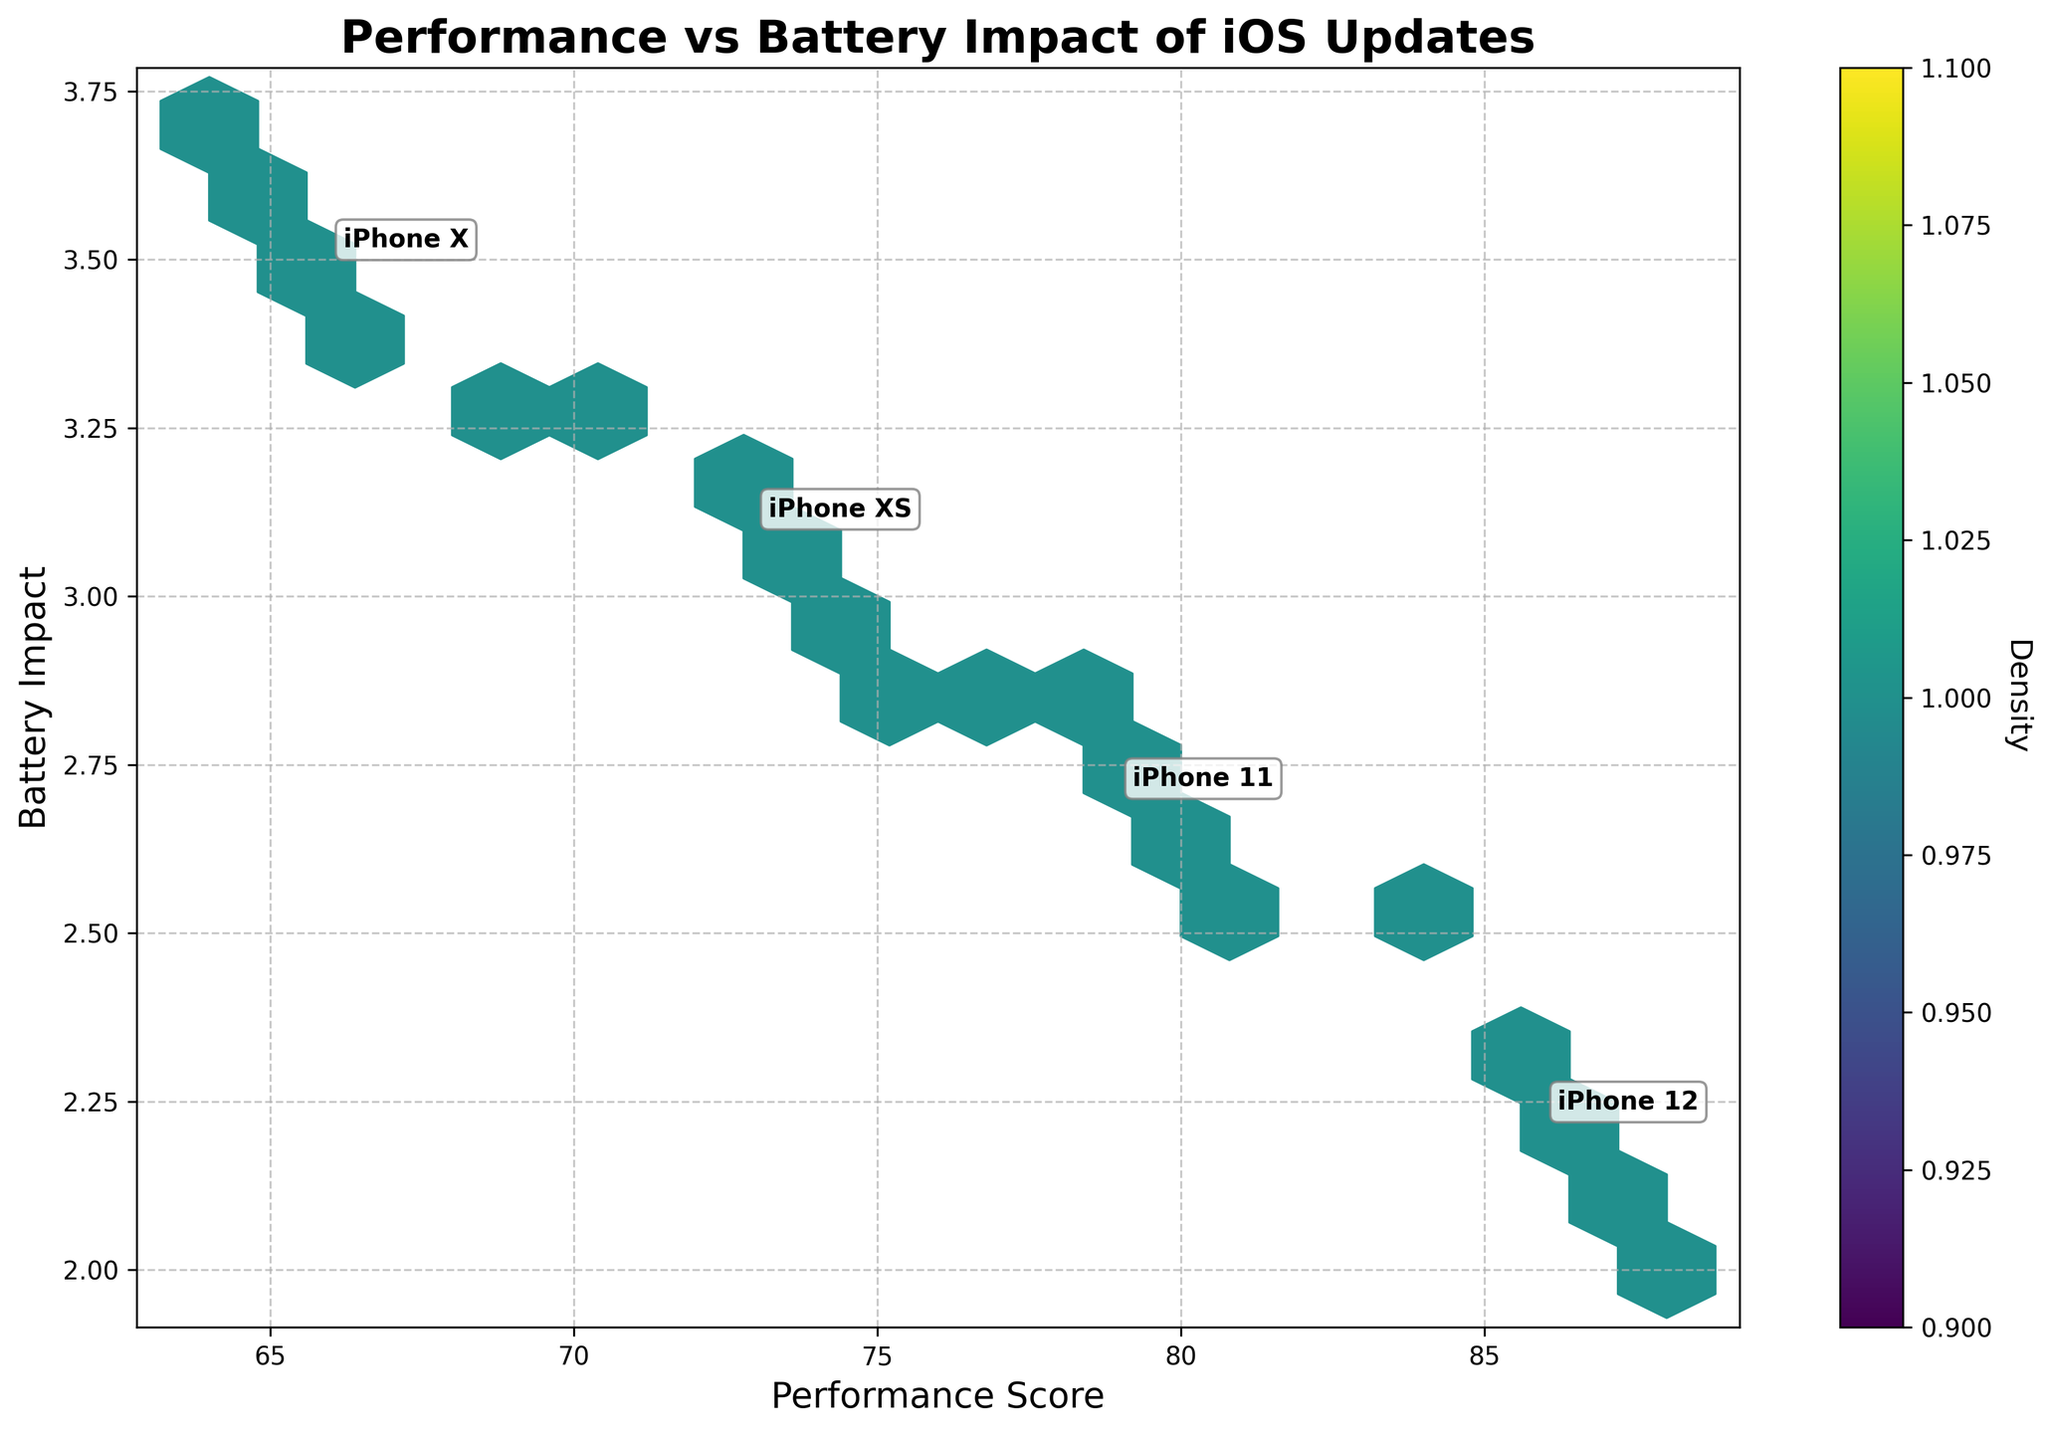what is the title of the plot? The title of the plot is always placed at the top of the figure. It summarizes what the figure is about. In this case, it's "Performance vs Battery Impact of iOS Updates".
Answer: Performance vs Battery Impact of iOS Updates What does the x-axis represent? The x-axis title tells us what the data on the horizontal axis is about. Here, it represents the "Performance Score".
Answer: Performance Score Which device model annotation appears near a performance score of 65? By looking at the annotations placed near performance scores, we see that "iPhone X" appears near the performance score of 65 which is located lower on the graph.
Answer: iPhone X Which device model has the highest average performance score? By examining the placement of annotations relative to the performance scores, we see that the iPhone 12 has a higher average performance score compared to the other models.
Answer: iPhone 12 What is the color of the densest area in the hexbin plot? The color map 'viridis' is used and the densest areas often appear in the brightest color. Thus, the densest area appears in bright yellow.
Answer: Bright Yellow How does the average battery impact differ between iPhone 12 and iPhone 11? Find the annotations for iPhone 12 and iPhone 11, compare the average battery impact values indicated by the placement on y-axis. iPhone 12 hovers around 2.2 and iPhone 11 hovers around 2.7, showing a difference of approximately 0.5.
Answer: ~0.5 Comparing the iPhone XS and iPhone X, which has a higher density of performance scores around 75? The density is shown by the color intensity in hexbin plots. By comparing the color density around the performance score of 75 for both iPhone XS and iPhone X, iPhone XS displays a higher density.
Answer: iPhone XS Is there a clear relationship between performance score and battery impact? To determine this, we observe whether there is a trend or pattern in the hexbin plot. The points are scattered without a significant clear trendline. Hence, the relationship is not clear.
Answer: No clear relationship What is annotated at the average performance score of 68 and average battery impact of approximately 3.3? Looking at the annotated data points, the annotation for these values corresponds to "iPhone X".
Answer: iPhone X 